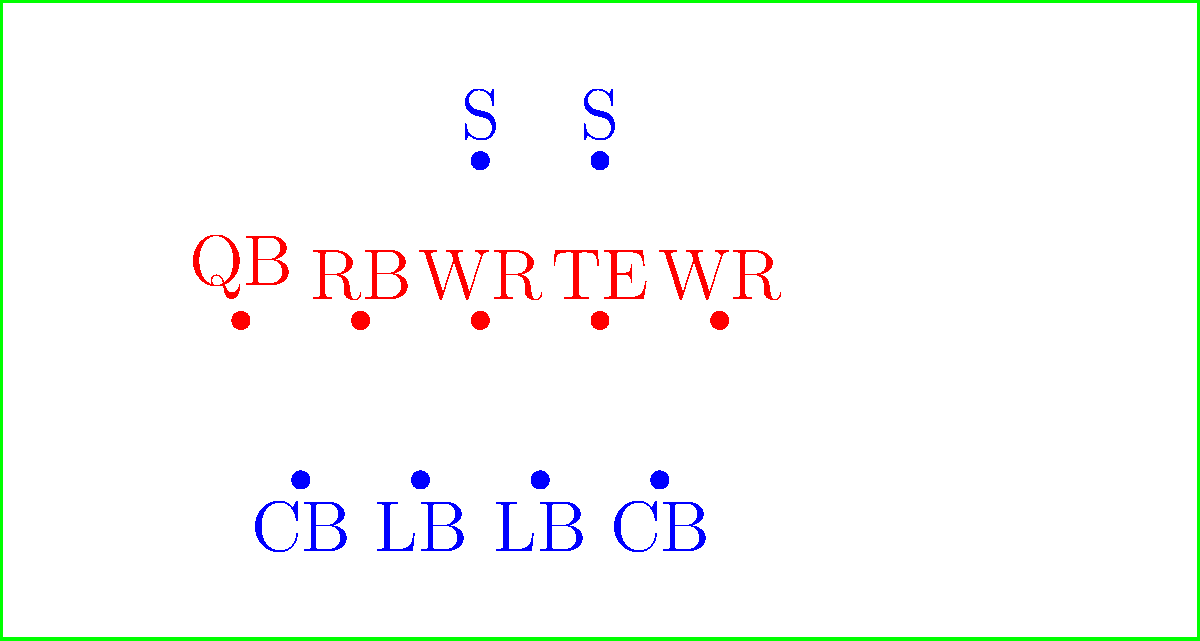Analyzing the offensive formation shown in the diagram, what type of play would be most effective against the defensive alignment, and why? To answer this question, let's break down the offensive and defensive formations:

1. Offensive Formation:
   - 1 QB (Quarterback)
   - 1 RB (Running Back)
   - 2 WR (Wide Receivers)
   - 1 TE (Tight End)
   This appears to be a Spread formation with multiple receiving options.

2. Defensive Formation:
   - 4 players in the box (not shown, but implied)
   - 2 LB (Linebackers)
   - 2 CB (Cornerbacks)
   - 2 S (Safeties)
   This resembles a 4-2-5 Nickel defense, designed to defend against passing plays.

3. Analyzing the matchups:
   - The defense has committed extra players to pass coverage with 5 defensive backs.
   - The linebackers are positioned relatively close to the line of scrimmage.
   - There's a potential mismatch with the TE against a linebacker or safety.

4. Optimal play choice:
   Given this analysis, a play-action pass would likely be most effective because:
   - It would initially draw the linebackers towards the line of scrimmage, creating space for passing lanes.
   - The TE could exploit the mismatch against a linebacker or safety.
   - The spread formation already puts pressure on the defensive backs, and a play-action could create confusion and separation.
   - The running back could provide an additional receiving option or stay in for pass protection.

5. Execution:
   The quarterback would fake a handoff to the running back, drawing in the linebackers, then look to pass to either the TE on a seam route or to one of the WRs if they've created separation.
Answer: Play-action pass 